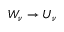Convert formula to latex. <formula><loc_0><loc_0><loc_500><loc_500>W _ { \nu } \rightarrow U _ { \nu }</formula> 